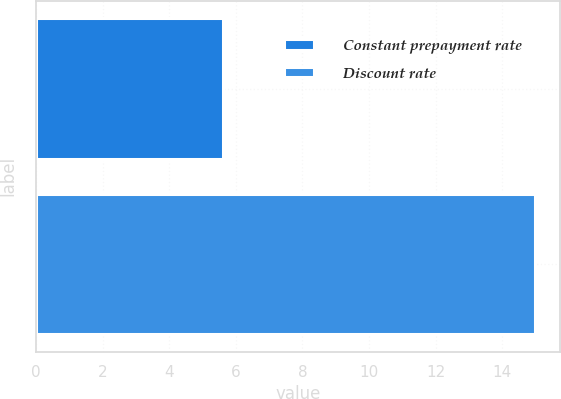Convert chart. <chart><loc_0><loc_0><loc_500><loc_500><bar_chart><fcel>Constant prepayment rate<fcel>Discount rate<nl><fcel>5.6<fcel>15<nl></chart> 